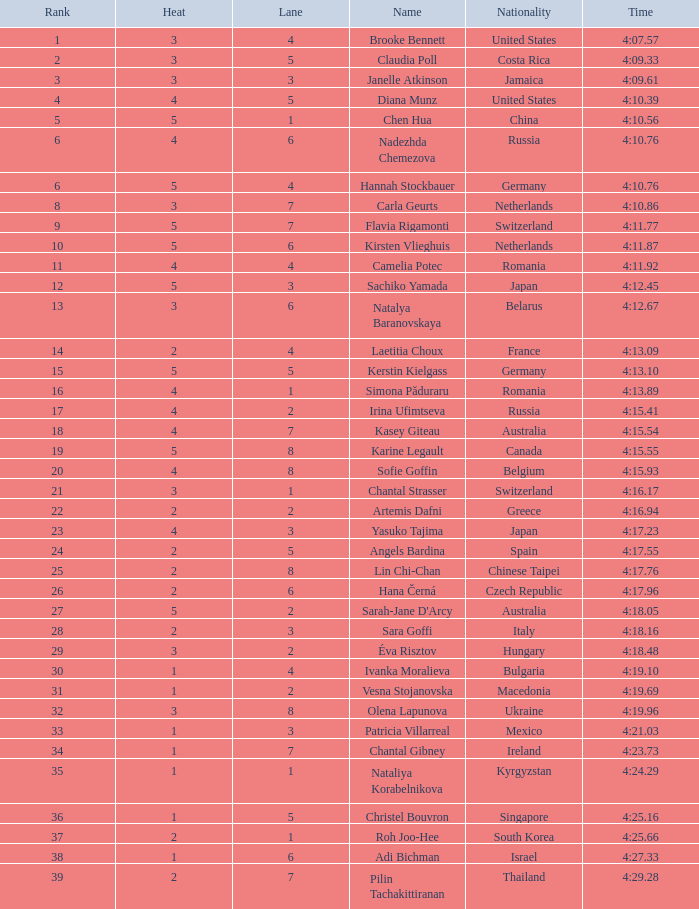Name the total number of lane for brooke bennett and rank less than 1 0.0. 